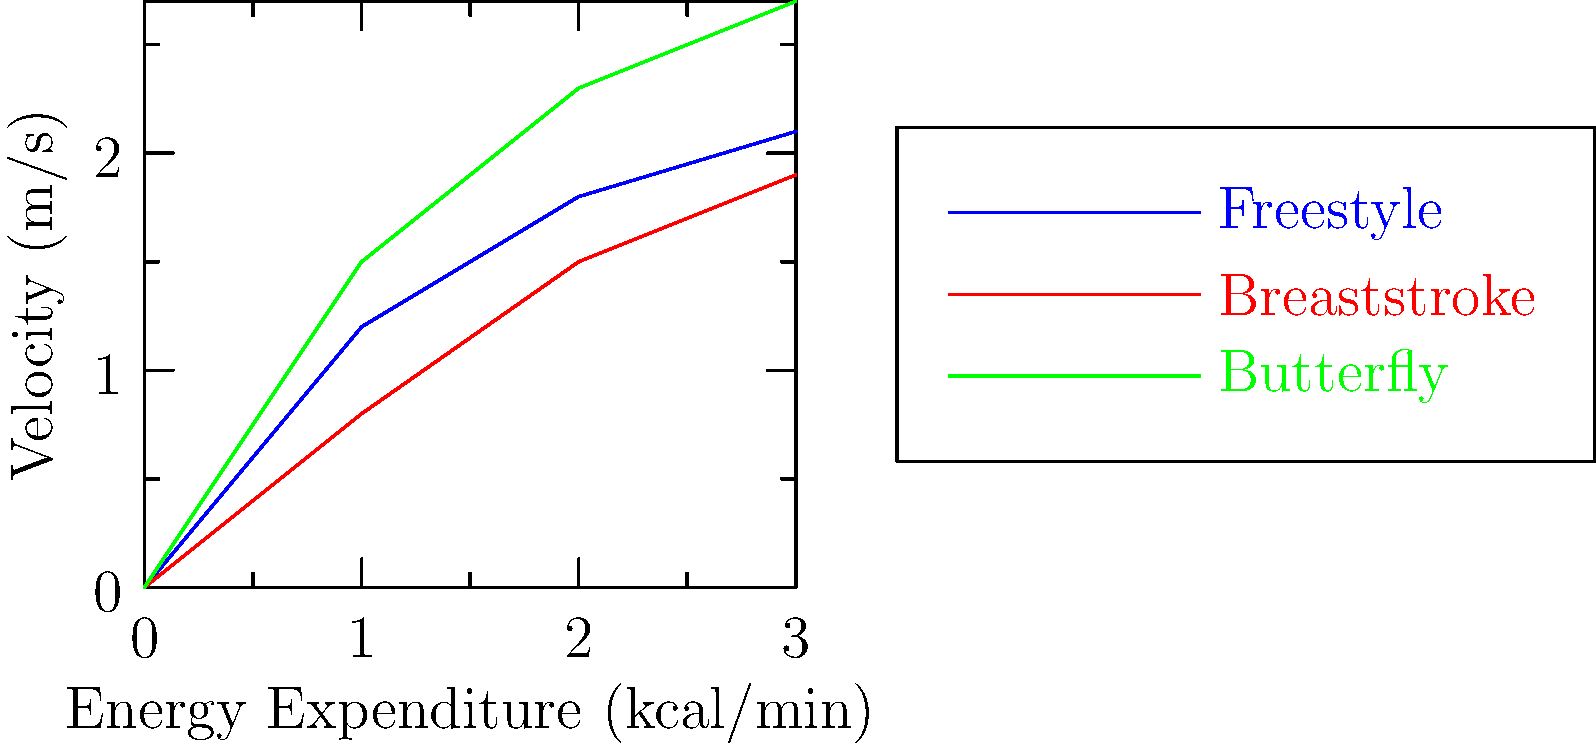Based on the graph showing the relationship between energy expenditure and velocity for different swimming strokes, which stroke demonstrates the highest biomechanical efficiency in terms of velocity gained per unit of energy expended? To determine the biomechanical efficiency of each swimming stroke, we need to analyze the rate of velocity increase relative to energy expenditure:

1. Freestyle (blue line):
   - Slope ≈ (2.1 - 0) / (3 - 0) = 0.7 m/s per kcal/min

2. Breaststroke (red line):
   - Slope ≈ (1.9 - 0) / (3 - 0) = 0.63 m/s per kcal/min

3. Butterfly (green line):
   - Slope ≈ (2.7 - 0) / (3 - 0) = 0.9 m/s per kcal/min

The stroke with the steepest slope demonstrates the highest efficiency, as it gains the most velocity per unit of energy expended.

Butterfly has the steepest slope, indicating it is the most efficient in terms of velocity gained per unit of energy expended.

This analysis assumes a linear relationship between energy expenditure and velocity, which is a simplification of the complex biomechanics involved in swimming.
Answer: Butterfly 